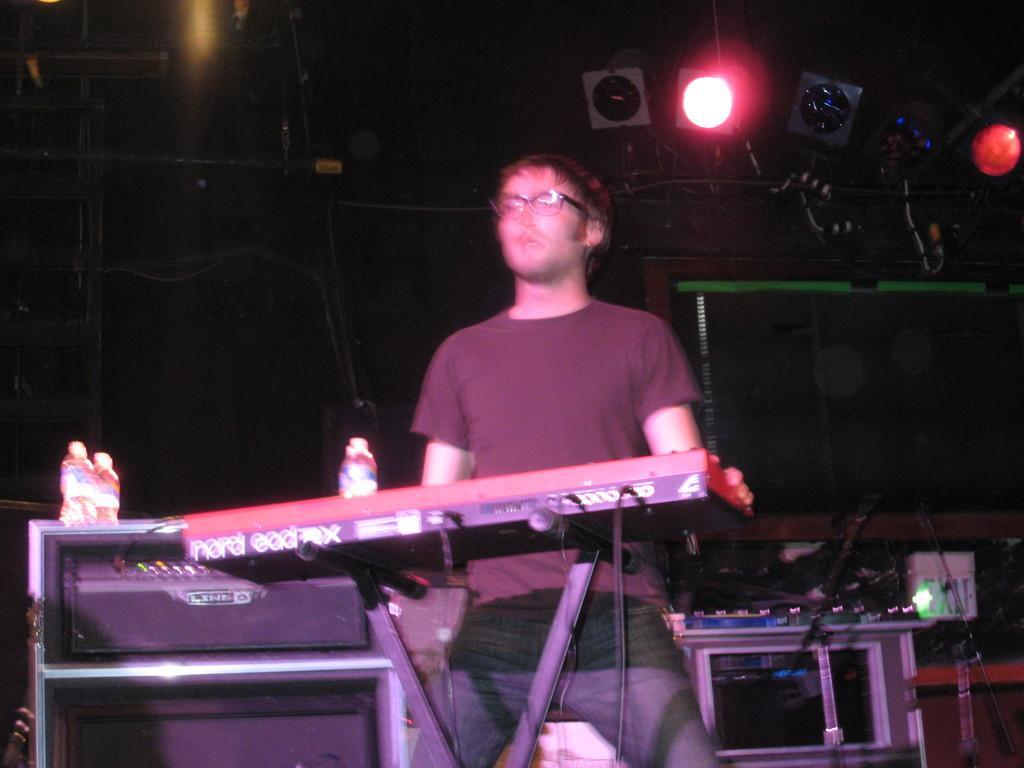In one or two sentences, can you explain what this image depicts? In this image I can see a man wearing t-shirt, jeans and standing. In front of this man there is a piano. In the background, I can see some more musical instruments. At the top there are few lights. The background is in black color. 